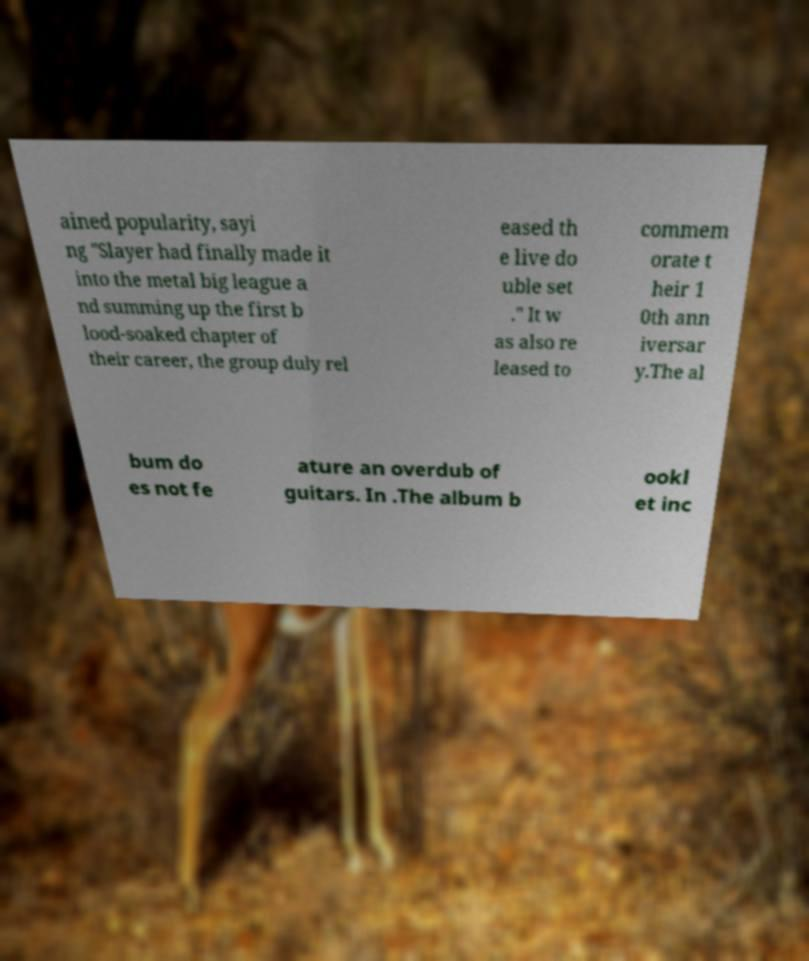Please identify and transcribe the text found in this image. ained popularity, sayi ng "Slayer had finally made it into the metal big league a nd summing up the first b lood-soaked chapter of their career, the group duly rel eased th e live do uble set ." It w as also re leased to commem orate t heir 1 0th ann iversar y.The al bum do es not fe ature an overdub of guitars. In .The album b ookl et inc 